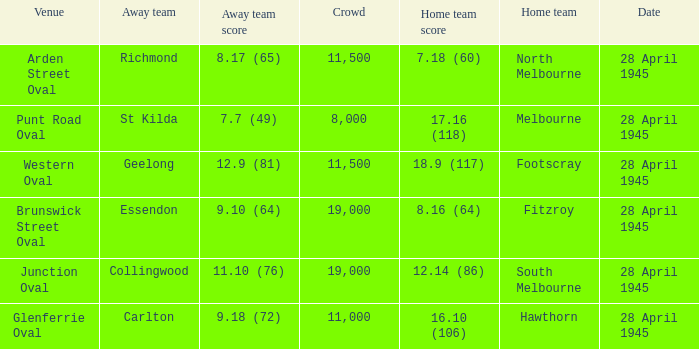Which home team has an Away team of essendon? 8.16 (64). 